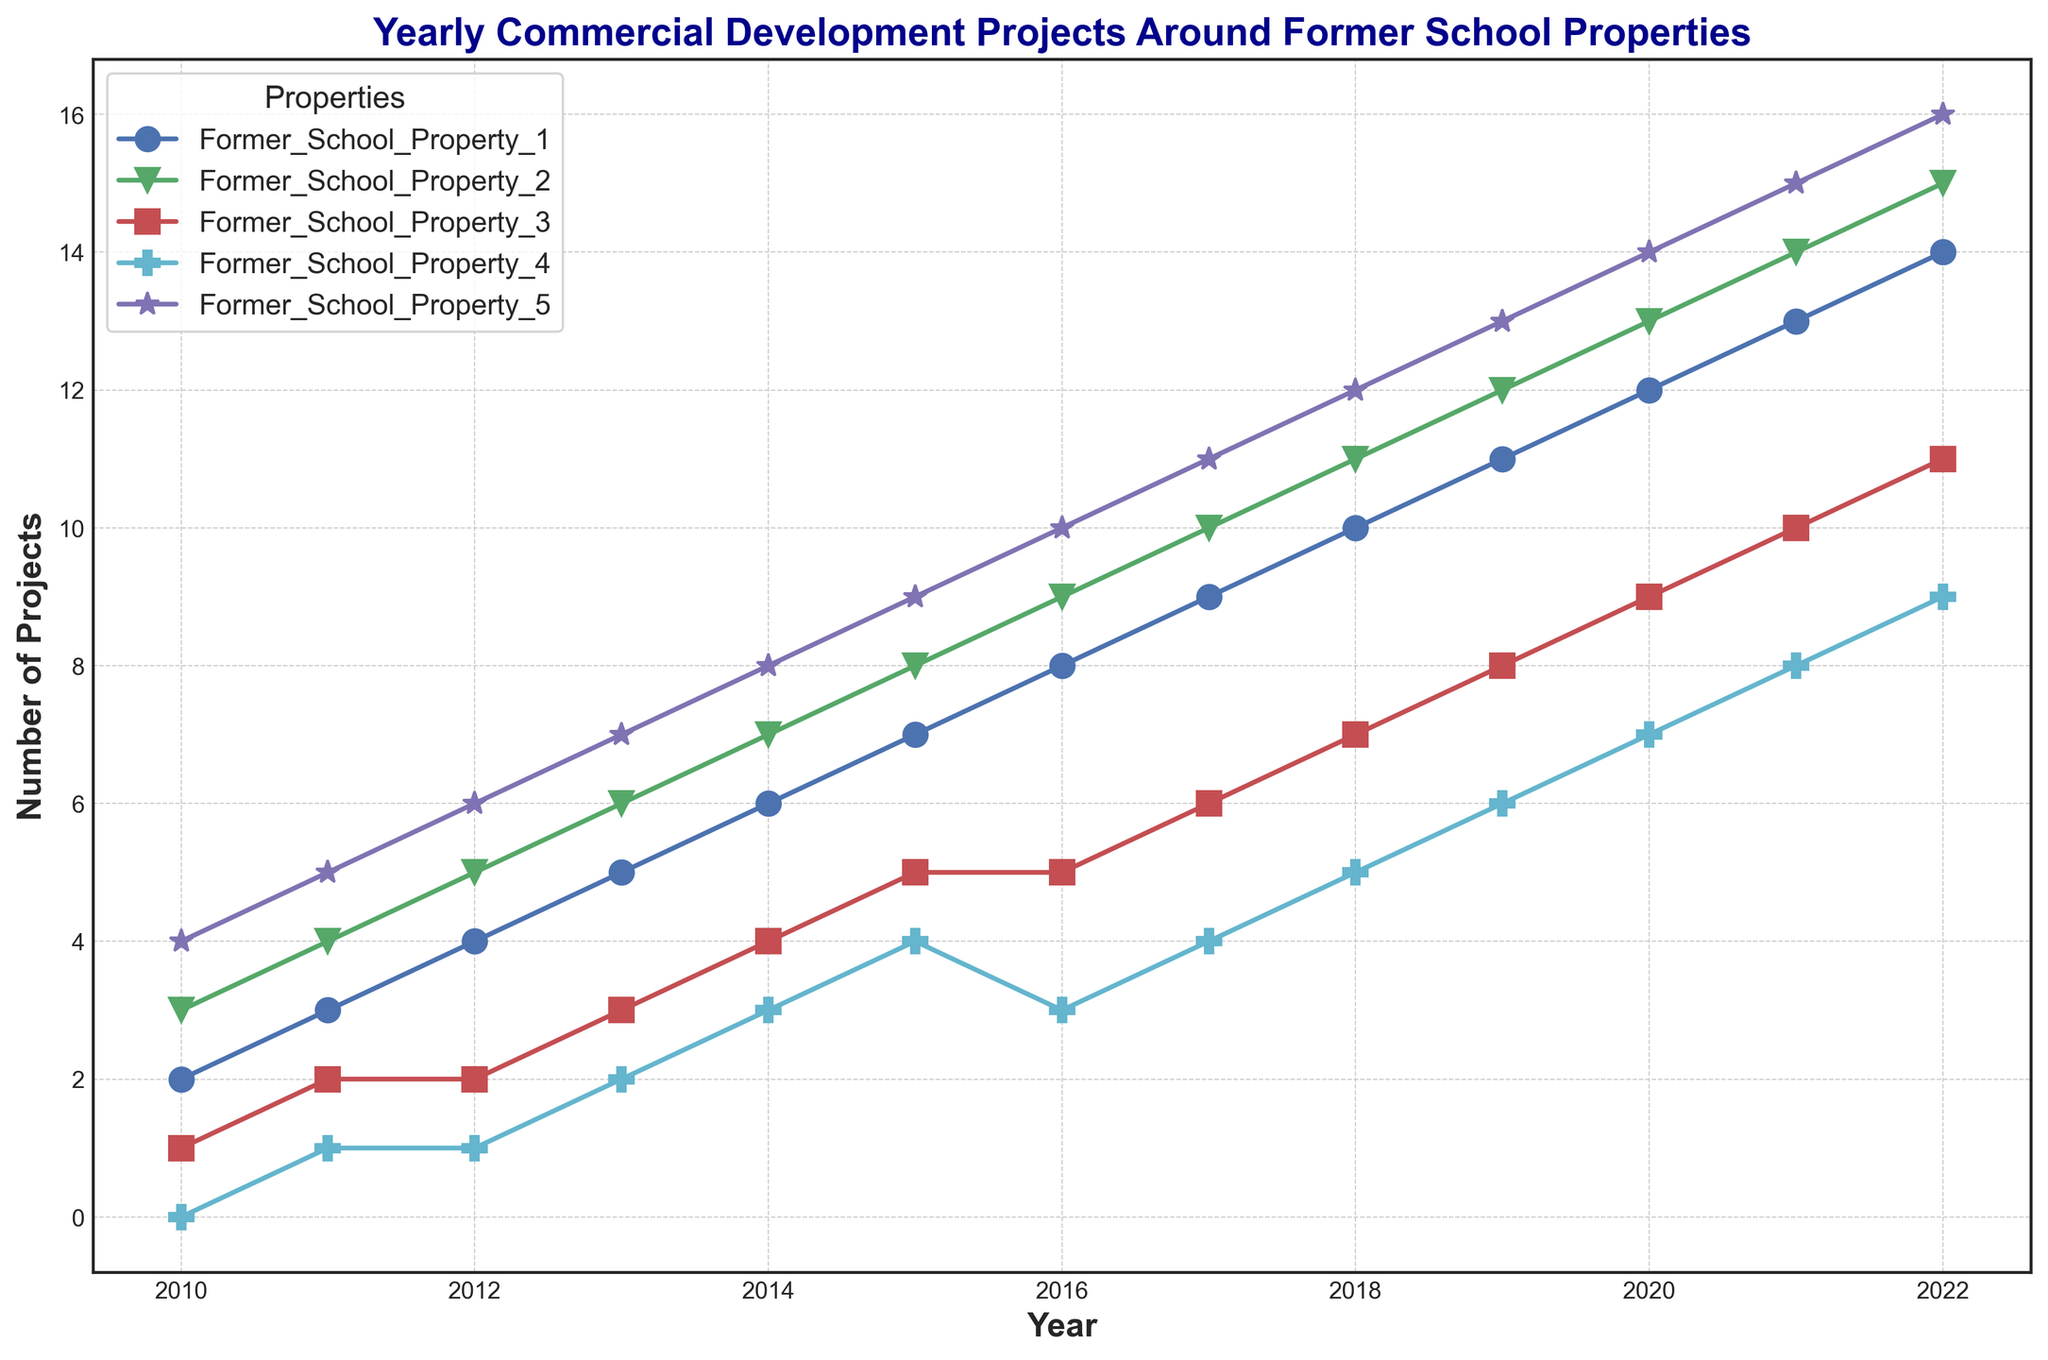What is the total number of projects for Former School Property 1 in 2012 and 2013? Look at the data points for Former School Property 1 in 2012 and 2013. The values are 4 and 5 respectively. Add them together: 4 + 5 = 9
Answer: 9 Which former school property saw the highest number of projects in 2022? Compare the data points for each property in 2022. The values are: Property 1 (14), Property 2 (15), Property 3 (11), Property 4 (9), Property 5 (16). Property 5 has the highest value of 16.
Answer: Former School Property 5 What is the average number of projects for Former School Property 3 from 2010 to 2022? Add up the values for Former School Property 3 from 2010 to 2022: 1 + 2 + 2 + 3 + 4 + 5 + 5 + 6 + 7 + 8 + 9 + 10 + 11 = 73. Then divide by 13 (total years): 73 / 13 = 5.615
Answer: 5.615 Which year had the least number of projects for Former School Property 4? Look at the values for Former School Property 4 from the years 2010 to 2022 and identify the smallest value. The values are: 0, 1, 1, 2, 3, 4, 3, 4, 5, 6, 7, 8, 9. The smallest value is 0 in 2010.
Answer: 2010 Which former school property saw a consistent increase in the number of projects every year from 2010 to 2022? Check each property's yearly data to see if there's a consistent increase every year. Former School Property 1, 2, 5 show a consistent increase in the number of projects each year. Compare them and see if they have no decrease at any year.
Answer: Former School Property 1, 2, 5 In which year did Former School Property 5 surpass 10 projects for the first time? Look at the values for Former School Property 5 and identify the first year where the number is greater than 10. The values are: 4, 5, 6, 7, 8, 9, 10, 11, 12, 13, 14, 15, 16. The first occurrence above 10 is in 2017.
Answer: 2017 Between 2010 and 2015, which property had the highest total number of projects? Sum the values of each property from 2010 to 2015. Property 1: 2+3+4+5+6+7 = 27, Property 2: 3+4+5+6+7+8 = 33, Property 3: 1+2+2+3+4+5 = 17, Property 4: 0+1+1+2+3+4 = 11, Property 5: 4+5+6+7+8+9 = 39. Property 5 has the highest total of 39.
Answer: Former School Property 5 How much did the number of projects for Former School Property 2 increase from 2010 to 2022? Subtract the number of projects in 2010 from those in 2022 for Former School Property 2. The values are 3 and 15 respectively. 15 - 3 = 12
Answer: 12 What is the difference in the number of projects between Former School Property 3 and Former School Property 4 in 2020? Look at the data points for both properties in 2020. Property 3 has 9 projects and Property 4 has 7 projects. The difference is 9 - 7 = 2
Answer: 2 In which year did Former School Property 4 reach the same number of projects as Former School Property 1 in 2010? Look at the number of projects for Former School Property 1 in 2010, which is 2. Find the year when Former School Property 4 also had 2 projects. This occurred in 2013.
Answer: 2013 